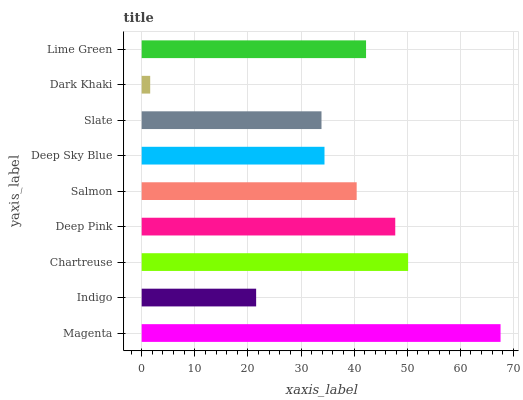Is Dark Khaki the minimum?
Answer yes or no. Yes. Is Magenta the maximum?
Answer yes or no. Yes. Is Indigo the minimum?
Answer yes or no. No. Is Indigo the maximum?
Answer yes or no. No. Is Magenta greater than Indigo?
Answer yes or no. Yes. Is Indigo less than Magenta?
Answer yes or no. Yes. Is Indigo greater than Magenta?
Answer yes or no. No. Is Magenta less than Indigo?
Answer yes or no. No. Is Salmon the high median?
Answer yes or no. Yes. Is Salmon the low median?
Answer yes or no. Yes. Is Slate the high median?
Answer yes or no. No. Is Chartreuse the low median?
Answer yes or no. No. 